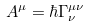Convert formula to latex. <formula><loc_0><loc_0><loc_500><loc_500>A ^ { \mu } = \hbar { \Gamma } ^ { \mu \nu } _ { \nu }</formula> 